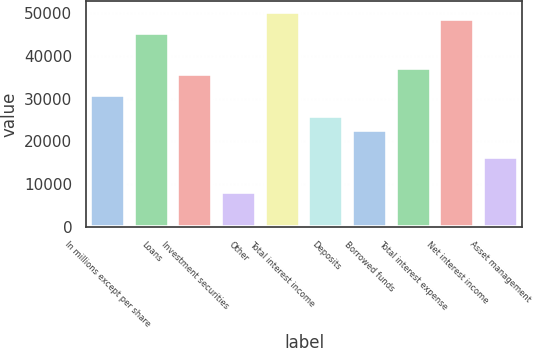<chart> <loc_0><loc_0><loc_500><loc_500><bar_chart><fcel>In millions except per share<fcel>Loans<fcel>Investment securities<fcel>Other<fcel>Total interest income<fcel>Deposits<fcel>Borrowed funds<fcel>Total interest expense<fcel>Net interest income<fcel>Asset management<nl><fcel>30829.3<fcel>45430.6<fcel>35696.4<fcel>8116.11<fcel>50297.7<fcel>25962.2<fcel>22717.4<fcel>37318.8<fcel>48675.4<fcel>16228<nl></chart> 